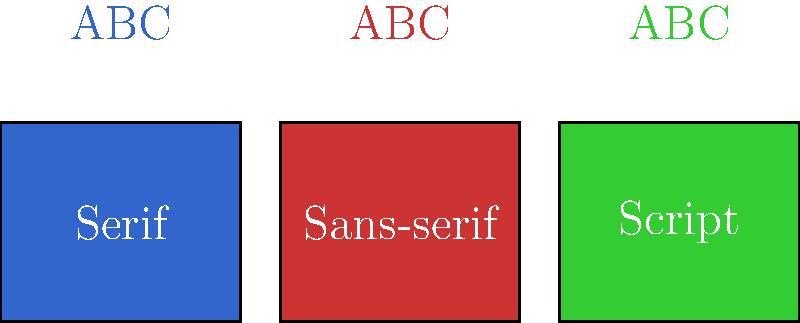As a new brand designer, you're working on a personal project for a modern tech startup. Which font style from the options shown in the image would be most appropriate for creating a professional and contemporary brand identity? To choose the most appropriate font for a modern tech startup's brand identity, let's consider each option:

1. Serif fonts:
   - Characterized by small decorative lines at the ends of letter strokes
   - Often associated with traditional, formal, or academic contexts
   - Can convey a sense of reliability and heritage

2. Sans-serif fonts:
   - Clean, simple letterforms without decorative lines
   - Associated with modernity, minimalism, and clarity
   - Widely used in digital interfaces and contemporary design

3. Script fonts:
   - Mimic handwriting or calligraphy
   - Often used for elegant, fancy, or personal branding
   - Can be difficult to read at small sizes or in large amounts of text

For a modern tech startup:
- The brand should convey innovation, simplicity, and professionalism
- Readability is crucial, especially for digital applications
- A clean, contemporary look is often preferred

Considering these factors, sans-serif fonts are the most appropriate choice. They offer:
- A modern, clean appearance that aligns with tech industry trends
- Excellent readability across various media and sizes
- Versatility for both digital and print applications
- A professional look that doesn't appear outdated or overly decorative

While serif fonts can work for some tech brands aiming for a more traditional feel, and script fonts might suit certain creative or personal brands, sans-serif fonts are generally the safest and most effective choice for a modern tech startup looking to create a professional and contemporary brand identity.
Answer: Sans-serif fonts 